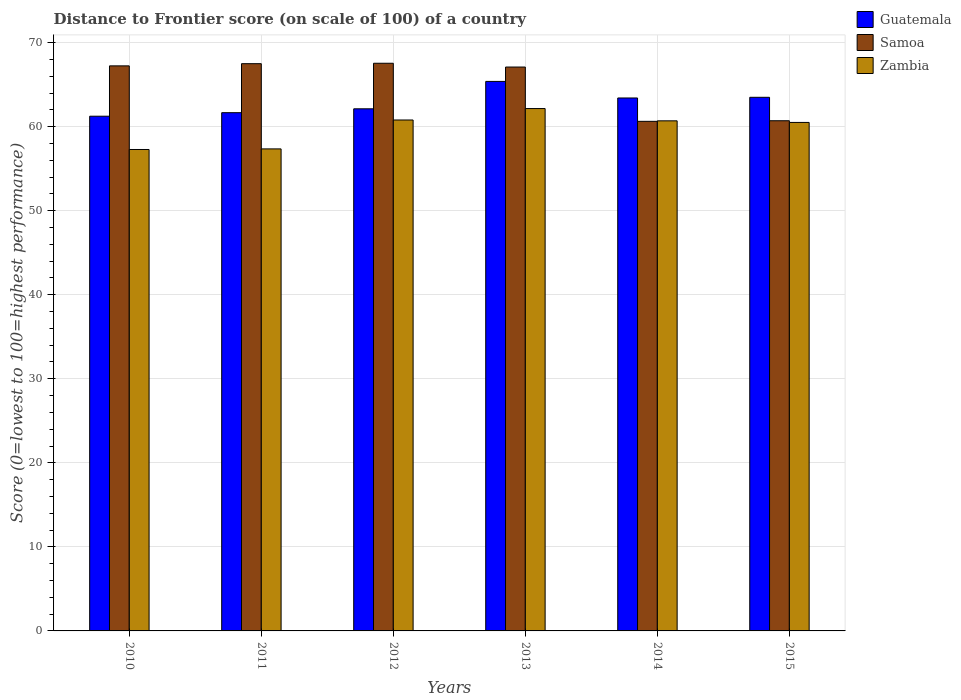How many different coloured bars are there?
Your response must be concise. 3. Are the number of bars on each tick of the X-axis equal?
Ensure brevity in your answer.  Yes. How many bars are there on the 4th tick from the left?
Your answer should be compact. 3. How many bars are there on the 2nd tick from the right?
Offer a terse response. 3. What is the label of the 1st group of bars from the left?
Your response must be concise. 2010. In how many cases, is the number of bars for a given year not equal to the number of legend labels?
Provide a succinct answer. 0. What is the distance to frontier score of in Guatemala in 2012?
Your answer should be compact. 62.12. Across all years, what is the maximum distance to frontier score of in Samoa?
Provide a succinct answer. 67.54. Across all years, what is the minimum distance to frontier score of in Zambia?
Make the answer very short. 57.28. What is the total distance to frontier score of in Guatemala in the graph?
Offer a very short reply. 377.3. What is the difference between the distance to frontier score of in Samoa in 2012 and that in 2014?
Offer a terse response. 6.91. What is the difference between the distance to frontier score of in Samoa in 2015 and the distance to frontier score of in Guatemala in 2012?
Offer a terse response. -1.42. What is the average distance to frontier score of in Samoa per year?
Provide a short and direct response. 65.11. In the year 2014, what is the difference between the distance to frontier score of in Samoa and distance to frontier score of in Zambia?
Your answer should be compact. -0.06. What is the ratio of the distance to frontier score of in Guatemala in 2010 to that in 2014?
Give a very brief answer. 0.97. Is the distance to frontier score of in Zambia in 2011 less than that in 2012?
Your answer should be compact. Yes. What is the difference between the highest and the second highest distance to frontier score of in Samoa?
Your answer should be compact. 0.05. What is the difference between the highest and the lowest distance to frontier score of in Zambia?
Offer a terse response. 4.87. Is the sum of the distance to frontier score of in Guatemala in 2012 and 2013 greater than the maximum distance to frontier score of in Samoa across all years?
Keep it short and to the point. Yes. What does the 2nd bar from the left in 2015 represents?
Make the answer very short. Samoa. What does the 2nd bar from the right in 2014 represents?
Ensure brevity in your answer.  Samoa. Is it the case that in every year, the sum of the distance to frontier score of in Zambia and distance to frontier score of in Samoa is greater than the distance to frontier score of in Guatemala?
Your answer should be compact. Yes. How many years are there in the graph?
Offer a terse response. 6. Does the graph contain grids?
Provide a succinct answer. Yes. Where does the legend appear in the graph?
Keep it short and to the point. Top right. How are the legend labels stacked?
Provide a short and direct response. Vertical. What is the title of the graph?
Give a very brief answer. Distance to Frontier score (on scale of 100) of a country. Does "Venezuela" appear as one of the legend labels in the graph?
Offer a terse response. No. What is the label or title of the X-axis?
Offer a terse response. Years. What is the label or title of the Y-axis?
Your response must be concise. Score (0=lowest to 100=highest performance). What is the Score (0=lowest to 100=highest performance) of Guatemala in 2010?
Your response must be concise. 61.24. What is the Score (0=lowest to 100=highest performance) in Samoa in 2010?
Your answer should be very brief. 67.23. What is the Score (0=lowest to 100=highest performance) of Zambia in 2010?
Provide a succinct answer. 57.28. What is the Score (0=lowest to 100=highest performance) of Guatemala in 2011?
Provide a succinct answer. 61.66. What is the Score (0=lowest to 100=highest performance) in Samoa in 2011?
Offer a terse response. 67.49. What is the Score (0=lowest to 100=highest performance) of Zambia in 2011?
Ensure brevity in your answer.  57.35. What is the Score (0=lowest to 100=highest performance) of Guatemala in 2012?
Your answer should be very brief. 62.12. What is the Score (0=lowest to 100=highest performance) in Samoa in 2012?
Offer a very short reply. 67.54. What is the Score (0=lowest to 100=highest performance) in Zambia in 2012?
Provide a short and direct response. 60.79. What is the Score (0=lowest to 100=highest performance) in Guatemala in 2013?
Make the answer very short. 65.38. What is the Score (0=lowest to 100=highest performance) of Samoa in 2013?
Ensure brevity in your answer.  67.09. What is the Score (0=lowest to 100=highest performance) in Zambia in 2013?
Your answer should be very brief. 62.15. What is the Score (0=lowest to 100=highest performance) of Guatemala in 2014?
Make the answer very short. 63.41. What is the Score (0=lowest to 100=highest performance) of Samoa in 2014?
Your response must be concise. 60.63. What is the Score (0=lowest to 100=highest performance) of Zambia in 2014?
Give a very brief answer. 60.69. What is the Score (0=lowest to 100=highest performance) of Guatemala in 2015?
Make the answer very short. 63.49. What is the Score (0=lowest to 100=highest performance) in Samoa in 2015?
Keep it short and to the point. 60.7. What is the Score (0=lowest to 100=highest performance) in Zambia in 2015?
Provide a short and direct response. 60.5. Across all years, what is the maximum Score (0=lowest to 100=highest performance) in Guatemala?
Provide a short and direct response. 65.38. Across all years, what is the maximum Score (0=lowest to 100=highest performance) of Samoa?
Provide a short and direct response. 67.54. Across all years, what is the maximum Score (0=lowest to 100=highest performance) of Zambia?
Your response must be concise. 62.15. Across all years, what is the minimum Score (0=lowest to 100=highest performance) in Guatemala?
Provide a short and direct response. 61.24. Across all years, what is the minimum Score (0=lowest to 100=highest performance) in Samoa?
Provide a succinct answer. 60.63. Across all years, what is the minimum Score (0=lowest to 100=highest performance) of Zambia?
Your answer should be very brief. 57.28. What is the total Score (0=lowest to 100=highest performance) in Guatemala in the graph?
Provide a succinct answer. 377.3. What is the total Score (0=lowest to 100=highest performance) in Samoa in the graph?
Your answer should be very brief. 390.68. What is the total Score (0=lowest to 100=highest performance) in Zambia in the graph?
Your answer should be very brief. 358.76. What is the difference between the Score (0=lowest to 100=highest performance) in Guatemala in 2010 and that in 2011?
Provide a short and direct response. -0.42. What is the difference between the Score (0=lowest to 100=highest performance) of Samoa in 2010 and that in 2011?
Your response must be concise. -0.26. What is the difference between the Score (0=lowest to 100=highest performance) in Zambia in 2010 and that in 2011?
Your response must be concise. -0.07. What is the difference between the Score (0=lowest to 100=highest performance) of Guatemala in 2010 and that in 2012?
Ensure brevity in your answer.  -0.88. What is the difference between the Score (0=lowest to 100=highest performance) of Samoa in 2010 and that in 2012?
Make the answer very short. -0.31. What is the difference between the Score (0=lowest to 100=highest performance) in Zambia in 2010 and that in 2012?
Your answer should be very brief. -3.51. What is the difference between the Score (0=lowest to 100=highest performance) in Guatemala in 2010 and that in 2013?
Your response must be concise. -4.14. What is the difference between the Score (0=lowest to 100=highest performance) of Samoa in 2010 and that in 2013?
Give a very brief answer. 0.14. What is the difference between the Score (0=lowest to 100=highest performance) of Zambia in 2010 and that in 2013?
Provide a short and direct response. -4.87. What is the difference between the Score (0=lowest to 100=highest performance) in Guatemala in 2010 and that in 2014?
Provide a short and direct response. -2.17. What is the difference between the Score (0=lowest to 100=highest performance) in Zambia in 2010 and that in 2014?
Ensure brevity in your answer.  -3.41. What is the difference between the Score (0=lowest to 100=highest performance) of Guatemala in 2010 and that in 2015?
Offer a very short reply. -2.25. What is the difference between the Score (0=lowest to 100=highest performance) in Samoa in 2010 and that in 2015?
Your answer should be very brief. 6.53. What is the difference between the Score (0=lowest to 100=highest performance) of Zambia in 2010 and that in 2015?
Your response must be concise. -3.22. What is the difference between the Score (0=lowest to 100=highest performance) of Guatemala in 2011 and that in 2012?
Give a very brief answer. -0.46. What is the difference between the Score (0=lowest to 100=highest performance) of Samoa in 2011 and that in 2012?
Your response must be concise. -0.05. What is the difference between the Score (0=lowest to 100=highest performance) in Zambia in 2011 and that in 2012?
Your response must be concise. -3.44. What is the difference between the Score (0=lowest to 100=highest performance) in Guatemala in 2011 and that in 2013?
Your answer should be compact. -3.72. What is the difference between the Score (0=lowest to 100=highest performance) of Zambia in 2011 and that in 2013?
Make the answer very short. -4.8. What is the difference between the Score (0=lowest to 100=highest performance) in Guatemala in 2011 and that in 2014?
Offer a very short reply. -1.75. What is the difference between the Score (0=lowest to 100=highest performance) in Samoa in 2011 and that in 2014?
Your answer should be compact. 6.86. What is the difference between the Score (0=lowest to 100=highest performance) of Zambia in 2011 and that in 2014?
Your answer should be very brief. -3.34. What is the difference between the Score (0=lowest to 100=highest performance) of Guatemala in 2011 and that in 2015?
Keep it short and to the point. -1.83. What is the difference between the Score (0=lowest to 100=highest performance) in Samoa in 2011 and that in 2015?
Make the answer very short. 6.79. What is the difference between the Score (0=lowest to 100=highest performance) in Zambia in 2011 and that in 2015?
Ensure brevity in your answer.  -3.15. What is the difference between the Score (0=lowest to 100=highest performance) in Guatemala in 2012 and that in 2013?
Offer a very short reply. -3.26. What is the difference between the Score (0=lowest to 100=highest performance) of Samoa in 2012 and that in 2013?
Your response must be concise. 0.45. What is the difference between the Score (0=lowest to 100=highest performance) of Zambia in 2012 and that in 2013?
Ensure brevity in your answer.  -1.36. What is the difference between the Score (0=lowest to 100=highest performance) in Guatemala in 2012 and that in 2014?
Offer a terse response. -1.29. What is the difference between the Score (0=lowest to 100=highest performance) in Samoa in 2012 and that in 2014?
Offer a terse response. 6.91. What is the difference between the Score (0=lowest to 100=highest performance) in Guatemala in 2012 and that in 2015?
Offer a very short reply. -1.37. What is the difference between the Score (0=lowest to 100=highest performance) in Samoa in 2012 and that in 2015?
Keep it short and to the point. 6.84. What is the difference between the Score (0=lowest to 100=highest performance) of Zambia in 2012 and that in 2015?
Offer a very short reply. 0.29. What is the difference between the Score (0=lowest to 100=highest performance) in Guatemala in 2013 and that in 2014?
Give a very brief answer. 1.97. What is the difference between the Score (0=lowest to 100=highest performance) of Samoa in 2013 and that in 2014?
Provide a short and direct response. 6.46. What is the difference between the Score (0=lowest to 100=highest performance) of Zambia in 2013 and that in 2014?
Keep it short and to the point. 1.46. What is the difference between the Score (0=lowest to 100=highest performance) of Guatemala in 2013 and that in 2015?
Offer a very short reply. 1.89. What is the difference between the Score (0=lowest to 100=highest performance) of Samoa in 2013 and that in 2015?
Offer a terse response. 6.39. What is the difference between the Score (0=lowest to 100=highest performance) of Zambia in 2013 and that in 2015?
Provide a succinct answer. 1.65. What is the difference between the Score (0=lowest to 100=highest performance) of Guatemala in 2014 and that in 2015?
Your answer should be very brief. -0.08. What is the difference between the Score (0=lowest to 100=highest performance) of Samoa in 2014 and that in 2015?
Keep it short and to the point. -0.07. What is the difference between the Score (0=lowest to 100=highest performance) in Zambia in 2014 and that in 2015?
Provide a short and direct response. 0.19. What is the difference between the Score (0=lowest to 100=highest performance) in Guatemala in 2010 and the Score (0=lowest to 100=highest performance) in Samoa in 2011?
Make the answer very short. -6.25. What is the difference between the Score (0=lowest to 100=highest performance) of Guatemala in 2010 and the Score (0=lowest to 100=highest performance) of Zambia in 2011?
Make the answer very short. 3.89. What is the difference between the Score (0=lowest to 100=highest performance) in Samoa in 2010 and the Score (0=lowest to 100=highest performance) in Zambia in 2011?
Make the answer very short. 9.88. What is the difference between the Score (0=lowest to 100=highest performance) in Guatemala in 2010 and the Score (0=lowest to 100=highest performance) in Samoa in 2012?
Provide a succinct answer. -6.3. What is the difference between the Score (0=lowest to 100=highest performance) in Guatemala in 2010 and the Score (0=lowest to 100=highest performance) in Zambia in 2012?
Offer a terse response. 0.45. What is the difference between the Score (0=lowest to 100=highest performance) of Samoa in 2010 and the Score (0=lowest to 100=highest performance) of Zambia in 2012?
Your response must be concise. 6.44. What is the difference between the Score (0=lowest to 100=highest performance) in Guatemala in 2010 and the Score (0=lowest to 100=highest performance) in Samoa in 2013?
Your answer should be very brief. -5.85. What is the difference between the Score (0=lowest to 100=highest performance) of Guatemala in 2010 and the Score (0=lowest to 100=highest performance) of Zambia in 2013?
Give a very brief answer. -0.91. What is the difference between the Score (0=lowest to 100=highest performance) of Samoa in 2010 and the Score (0=lowest to 100=highest performance) of Zambia in 2013?
Make the answer very short. 5.08. What is the difference between the Score (0=lowest to 100=highest performance) of Guatemala in 2010 and the Score (0=lowest to 100=highest performance) of Samoa in 2014?
Make the answer very short. 0.61. What is the difference between the Score (0=lowest to 100=highest performance) of Guatemala in 2010 and the Score (0=lowest to 100=highest performance) of Zambia in 2014?
Your answer should be compact. 0.55. What is the difference between the Score (0=lowest to 100=highest performance) of Samoa in 2010 and the Score (0=lowest to 100=highest performance) of Zambia in 2014?
Offer a terse response. 6.54. What is the difference between the Score (0=lowest to 100=highest performance) of Guatemala in 2010 and the Score (0=lowest to 100=highest performance) of Samoa in 2015?
Provide a short and direct response. 0.54. What is the difference between the Score (0=lowest to 100=highest performance) of Guatemala in 2010 and the Score (0=lowest to 100=highest performance) of Zambia in 2015?
Offer a terse response. 0.74. What is the difference between the Score (0=lowest to 100=highest performance) in Samoa in 2010 and the Score (0=lowest to 100=highest performance) in Zambia in 2015?
Your answer should be compact. 6.73. What is the difference between the Score (0=lowest to 100=highest performance) of Guatemala in 2011 and the Score (0=lowest to 100=highest performance) of Samoa in 2012?
Give a very brief answer. -5.88. What is the difference between the Score (0=lowest to 100=highest performance) in Guatemala in 2011 and the Score (0=lowest to 100=highest performance) in Zambia in 2012?
Provide a succinct answer. 0.87. What is the difference between the Score (0=lowest to 100=highest performance) of Samoa in 2011 and the Score (0=lowest to 100=highest performance) of Zambia in 2012?
Offer a terse response. 6.7. What is the difference between the Score (0=lowest to 100=highest performance) in Guatemala in 2011 and the Score (0=lowest to 100=highest performance) in Samoa in 2013?
Provide a short and direct response. -5.43. What is the difference between the Score (0=lowest to 100=highest performance) of Guatemala in 2011 and the Score (0=lowest to 100=highest performance) of Zambia in 2013?
Provide a succinct answer. -0.49. What is the difference between the Score (0=lowest to 100=highest performance) of Samoa in 2011 and the Score (0=lowest to 100=highest performance) of Zambia in 2013?
Offer a very short reply. 5.34. What is the difference between the Score (0=lowest to 100=highest performance) of Guatemala in 2011 and the Score (0=lowest to 100=highest performance) of Samoa in 2014?
Offer a very short reply. 1.03. What is the difference between the Score (0=lowest to 100=highest performance) in Guatemala in 2011 and the Score (0=lowest to 100=highest performance) in Samoa in 2015?
Ensure brevity in your answer.  0.96. What is the difference between the Score (0=lowest to 100=highest performance) of Guatemala in 2011 and the Score (0=lowest to 100=highest performance) of Zambia in 2015?
Offer a very short reply. 1.16. What is the difference between the Score (0=lowest to 100=highest performance) in Samoa in 2011 and the Score (0=lowest to 100=highest performance) in Zambia in 2015?
Provide a short and direct response. 6.99. What is the difference between the Score (0=lowest to 100=highest performance) of Guatemala in 2012 and the Score (0=lowest to 100=highest performance) of Samoa in 2013?
Your answer should be compact. -4.97. What is the difference between the Score (0=lowest to 100=highest performance) of Guatemala in 2012 and the Score (0=lowest to 100=highest performance) of Zambia in 2013?
Provide a succinct answer. -0.03. What is the difference between the Score (0=lowest to 100=highest performance) in Samoa in 2012 and the Score (0=lowest to 100=highest performance) in Zambia in 2013?
Provide a short and direct response. 5.39. What is the difference between the Score (0=lowest to 100=highest performance) of Guatemala in 2012 and the Score (0=lowest to 100=highest performance) of Samoa in 2014?
Ensure brevity in your answer.  1.49. What is the difference between the Score (0=lowest to 100=highest performance) of Guatemala in 2012 and the Score (0=lowest to 100=highest performance) of Zambia in 2014?
Give a very brief answer. 1.43. What is the difference between the Score (0=lowest to 100=highest performance) in Samoa in 2012 and the Score (0=lowest to 100=highest performance) in Zambia in 2014?
Ensure brevity in your answer.  6.85. What is the difference between the Score (0=lowest to 100=highest performance) in Guatemala in 2012 and the Score (0=lowest to 100=highest performance) in Samoa in 2015?
Your answer should be compact. 1.42. What is the difference between the Score (0=lowest to 100=highest performance) of Guatemala in 2012 and the Score (0=lowest to 100=highest performance) of Zambia in 2015?
Make the answer very short. 1.62. What is the difference between the Score (0=lowest to 100=highest performance) in Samoa in 2012 and the Score (0=lowest to 100=highest performance) in Zambia in 2015?
Give a very brief answer. 7.04. What is the difference between the Score (0=lowest to 100=highest performance) in Guatemala in 2013 and the Score (0=lowest to 100=highest performance) in Samoa in 2014?
Provide a succinct answer. 4.75. What is the difference between the Score (0=lowest to 100=highest performance) of Guatemala in 2013 and the Score (0=lowest to 100=highest performance) of Zambia in 2014?
Your answer should be very brief. 4.69. What is the difference between the Score (0=lowest to 100=highest performance) of Samoa in 2013 and the Score (0=lowest to 100=highest performance) of Zambia in 2014?
Make the answer very short. 6.4. What is the difference between the Score (0=lowest to 100=highest performance) of Guatemala in 2013 and the Score (0=lowest to 100=highest performance) of Samoa in 2015?
Your answer should be very brief. 4.68. What is the difference between the Score (0=lowest to 100=highest performance) in Guatemala in 2013 and the Score (0=lowest to 100=highest performance) in Zambia in 2015?
Offer a terse response. 4.88. What is the difference between the Score (0=lowest to 100=highest performance) in Samoa in 2013 and the Score (0=lowest to 100=highest performance) in Zambia in 2015?
Give a very brief answer. 6.59. What is the difference between the Score (0=lowest to 100=highest performance) of Guatemala in 2014 and the Score (0=lowest to 100=highest performance) of Samoa in 2015?
Provide a short and direct response. 2.71. What is the difference between the Score (0=lowest to 100=highest performance) in Guatemala in 2014 and the Score (0=lowest to 100=highest performance) in Zambia in 2015?
Offer a terse response. 2.91. What is the difference between the Score (0=lowest to 100=highest performance) in Samoa in 2014 and the Score (0=lowest to 100=highest performance) in Zambia in 2015?
Your answer should be compact. 0.13. What is the average Score (0=lowest to 100=highest performance) in Guatemala per year?
Your response must be concise. 62.88. What is the average Score (0=lowest to 100=highest performance) in Samoa per year?
Keep it short and to the point. 65.11. What is the average Score (0=lowest to 100=highest performance) of Zambia per year?
Give a very brief answer. 59.79. In the year 2010, what is the difference between the Score (0=lowest to 100=highest performance) in Guatemala and Score (0=lowest to 100=highest performance) in Samoa?
Your answer should be compact. -5.99. In the year 2010, what is the difference between the Score (0=lowest to 100=highest performance) of Guatemala and Score (0=lowest to 100=highest performance) of Zambia?
Provide a succinct answer. 3.96. In the year 2010, what is the difference between the Score (0=lowest to 100=highest performance) in Samoa and Score (0=lowest to 100=highest performance) in Zambia?
Keep it short and to the point. 9.95. In the year 2011, what is the difference between the Score (0=lowest to 100=highest performance) in Guatemala and Score (0=lowest to 100=highest performance) in Samoa?
Provide a short and direct response. -5.83. In the year 2011, what is the difference between the Score (0=lowest to 100=highest performance) of Guatemala and Score (0=lowest to 100=highest performance) of Zambia?
Make the answer very short. 4.31. In the year 2011, what is the difference between the Score (0=lowest to 100=highest performance) in Samoa and Score (0=lowest to 100=highest performance) in Zambia?
Your answer should be compact. 10.14. In the year 2012, what is the difference between the Score (0=lowest to 100=highest performance) in Guatemala and Score (0=lowest to 100=highest performance) in Samoa?
Offer a terse response. -5.42. In the year 2012, what is the difference between the Score (0=lowest to 100=highest performance) of Guatemala and Score (0=lowest to 100=highest performance) of Zambia?
Your response must be concise. 1.33. In the year 2012, what is the difference between the Score (0=lowest to 100=highest performance) of Samoa and Score (0=lowest to 100=highest performance) of Zambia?
Provide a succinct answer. 6.75. In the year 2013, what is the difference between the Score (0=lowest to 100=highest performance) of Guatemala and Score (0=lowest to 100=highest performance) of Samoa?
Your response must be concise. -1.71. In the year 2013, what is the difference between the Score (0=lowest to 100=highest performance) in Guatemala and Score (0=lowest to 100=highest performance) in Zambia?
Offer a terse response. 3.23. In the year 2013, what is the difference between the Score (0=lowest to 100=highest performance) of Samoa and Score (0=lowest to 100=highest performance) of Zambia?
Provide a succinct answer. 4.94. In the year 2014, what is the difference between the Score (0=lowest to 100=highest performance) of Guatemala and Score (0=lowest to 100=highest performance) of Samoa?
Your answer should be very brief. 2.78. In the year 2014, what is the difference between the Score (0=lowest to 100=highest performance) in Guatemala and Score (0=lowest to 100=highest performance) in Zambia?
Your answer should be very brief. 2.72. In the year 2014, what is the difference between the Score (0=lowest to 100=highest performance) of Samoa and Score (0=lowest to 100=highest performance) of Zambia?
Keep it short and to the point. -0.06. In the year 2015, what is the difference between the Score (0=lowest to 100=highest performance) in Guatemala and Score (0=lowest to 100=highest performance) in Samoa?
Keep it short and to the point. 2.79. In the year 2015, what is the difference between the Score (0=lowest to 100=highest performance) in Guatemala and Score (0=lowest to 100=highest performance) in Zambia?
Provide a succinct answer. 2.99. In the year 2015, what is the difference between the Score (0=lowest to 100=highest performance) of Samoa and Score (0=lowest to 100=highest performance) of Zambia?
Offer a terse response. 0.2. What is the ratio of the Score (0=lowest to 100=highest performance) in Guatemala in 2010 to that in 2011?
Your response must be concise. 0.99. What is the ratio of the Score (0=lowest to 100=highest performance) of Guatemala in 2010 to that in 2012?
Your answer should be very brief. 0.99. What is the ratio of the Score (0=lowest to 100=highest performance) in Zambia in 2010 to that in 2012?
Your response must be concise. 0.94. What is the ratio of the Score (0=lowest to 100=highest performance) of Guatemala in 2010 to that in 2013?
Your answer should be very brief. 0.94. What is the ratio of the Score (0=lowest to 100=highest performance) of Zambia in 2010 to that in 2013?
Your answer should be very brief. 0.92. What is the ratio of the Score (0=lowest to 100=highest performance) in Guatemala in 2010 to that in 2014?
Ensure brevity in your answer.  0.97. What is the ratio of the Score (0=lowest to 100=highest performance) in Samoa in 2010 to that in 2014?
Your response must be concise. 1.11. What is the ratio of the Score (0=lowest to 100=highest performance) in Zambia in 2010 to that in 2014?
Offer a terse response. 0.94. What is the ratio of the Score (0=lowest to 100=highest performance) of Guatemala in 2010 to that in 2015?
Provide a succinct answer. 0.96. What is the ratio of the Score (0=lowest to 100=highest performance) in Samoa in 2010 to that in 2015?
Your answer should be compact. 1.11. What is the ratio of the Score (0=lowest to 100=highest performance) of Zambia in 2010 to that in 2015?
Provide a short and direct response. 0.95. What is the ratio of the Score (0=lowest to 100=highest performance) of Samoa in 2011 to that in 2012?
Offer a very short reply. 1. What is the ratio of the Score (0=lowest to 100=highest performance) of Zambia in 2011 to that in 2012?
Offer a terse response. 0.94. What is the ratio of the Score (0=lowest to 100=highest performance) of Guatemala in 2011 to that in 2013?
Your response must be concise. 0.94. What is the ratio of the Score (0=lowest to 100=highest performance) in Samoa in 2011 to that in 2013?
Offer a very short reply. 1.01. What is the ratio of the Score (0=lowest to 100=highest performance) in Zambia in 2011 to that in 2013?
Offer a very short reply. 0.92. What is the ratio of the Score (0=lowest to 100=highest performance) of Guatemala in 2011 to that in 2014?
Give a very brief answer. 0.97. What is the ratio of the Score (0=lowest to 100=highest performance) of Samoa in 2011 to that in 2014?
Offer a very short reply. 1.11. What is the ratio of the Score (0=lowest to 100=highest performance) in Zambia in 2011 to that in 2014?
Offer a very short reply. 0.94. What is the ratio of the Score (0=lowest to 100=highest performance) of Guatemala in 2011 to that in 2015?
Provide a succinct answer. 0.97. What is the ratio of the Score (0=lowest to 100=highest performance) of Samoa in 2011 to that in 2015?
Give a very brief answer. 1.11. What is the ratio of the Score (0=lowest to 100=highest performance) of Zambia in 2011 to that in 2015?
Provide a short and direct response. 0.95. What is the ratio of the Score (0=lowest to 100=highest performance) of Guatemala in 2012 to that in 2013?
Your answer should be very brief. 0.95. What is the ratio of the Score (0=lowest to 100=highest performance) in Samoa in 2012 to that in 2013?
Ensure brevity in your answer.  1.01. What is the ratio of the Score (0=lowest to 100=highest performance) in Zambia in 2012 to that in 2013?
Give a very brief answer. 0.98. What is the ratio of the Score (0=lowest to 100=highest performance) in Guatemala in 2012 to that in 2014?
Your answer should be very brief. 0.98. What is the ratio of the Score (0=lowest to 100=highest performance) of Samoa in 2012 to that in 2014?
Your answer should be very brief. 1.11. What is the ratio of the Score (0=lowest to 100=highest performance) in Zambia in 2012 to that in 2014?
Provide a succinct answer. 1. What is the ratio of the Score (0=lowest to 100=highest performance) of Guatemala in 2012 to that in 2015?
Give a very brief answer. 0.98. What is the ratio of the Score (0=lowest to 100=highest performance) of Samoa in 2012 to that in 2015?
Offer a terse response. 1.11. What is the ratio of the Score (0=lowest to 100=highest performance) in Zambia in 2012 to that in 2015?
Provide a short and direct response. 1. What is the ratio of the Score (0=lowest to 100=highest performance) of Guatemala in 2013 to that in 2014?
Make the answer very short. 1.03. What is the ratio of the Score (0=lowest to 100=highest performance) of Samoa in 2013 to that in 2014?
Provide a short and direct response. 1.11. What is the ratio of the Score (0=lowest to 100=highest performance) of Zambia in 2013 to that in 2014?
Give a very brief answer. 1.02. What is the ratio of the Score (0=lowest to 100=highest performance) of Guatemala in 2013 to that in 2015?
Make the answer very short. 1.03. What is the ratio of the Score (0=lowest to 100=highest performance) of Samoa in 2013 to that in 2015?
Your response must be concise. 1.11. What is the ratio of the Score (0=lowest to 100=highest performance) of Zambia in 2013 to that in 2015?
Provide a succinct answer. 1.03. What is the ratio of the Score (0=lowest to 100=highest performance) of Samoa in 2014 to that in 2015?
Offer a terse response. 1. What is the ratio of the Score (0=lowest to 100=highest performance) of Zambia in 2014 to that in 2015?
Give a very brief answer. 1. What is the difference between the highest and the second highest Score (0=lowest to 100=highest performance) of Guatemala?
Ensure brevity in your answer.  1.89. What is the difference between the highest and the second highest Score (0=lowest to 100=highest performance) of Samoa?
Your answer should be very brief. 0.05. What is the difference between the highest and the second highest Score (0=lowest to 100=highest performance) of Zambia?
Provide a short and direct response. 1.36. What is the difference between the highest and the lowest Score (0=lowest to 100=highest performance) in Guatemala?
Ensure brevity in your answer.  4.14. What is the difference between the highest and the lowest Score (0=lowest to 100=highest performance) in Samoa?
Keep it short and to the point. 6.91. What is the difference between the highest and the lowest Score (0=lowest to 100=highest performance) in Zambia?
Make the answer very short. 4.87. 